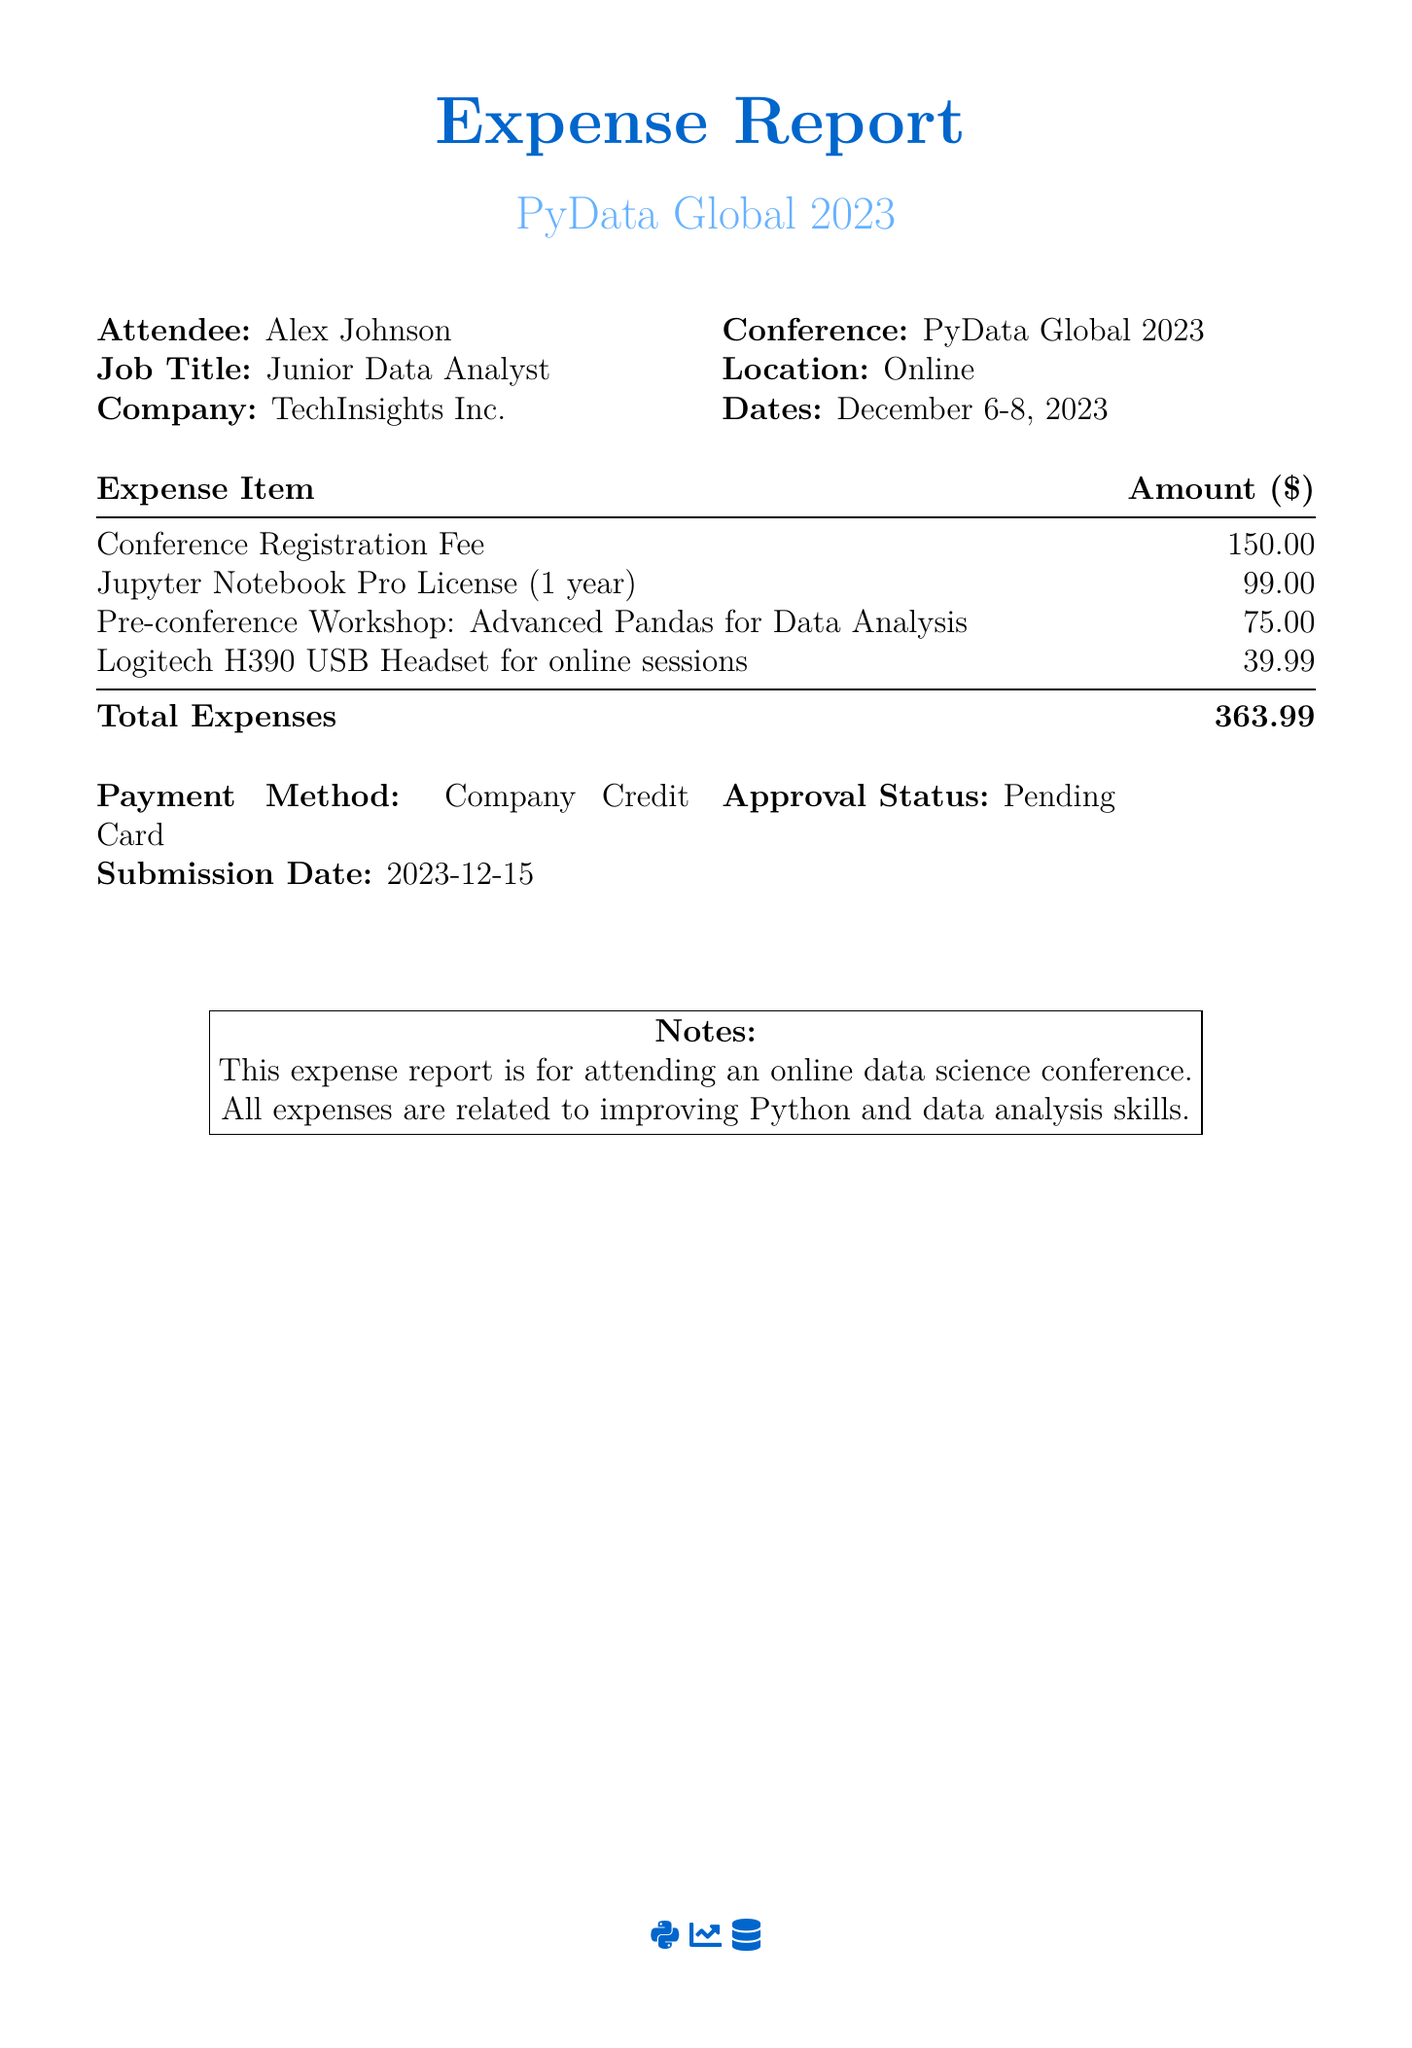what is the name of the attendee? The name of the attendee is listed in the document under "Attendee".
Answer: Alex Johnson what is the total amount of expenses? The total amount is found at the bottom of the expenses table.
Answer: 363.99 what was the location of the conference? The location is specified in the table where the conference details are mentioned.
Answer: Online what is the approval status for the expense report? The approval status can be found in the table detailing payment methods.
Answer: Pending how much was the conference registration fee? The conference registration fee is specifically listed in the expenses table.
Answer: 150.00 which workshop was attended before the conference? The document mentions a specific workshop that took place prior to the conference.
Answer: Advanced Pandas for Data Analysis when was the submission date of the expense report? The submission date is explicitly stated in the details provided in the table.
Answer: 2023-12-15 what payment method was used for the expenses? The payment method is detailed in the section covering payment and approval information.
Answer: Company Credit Card how much did the Jupyter Notebook Pro License cost? The cost of the Jupyter Notebook Pro License is directly listed in the expenses table.
Answer: 99.00 what is the purpose of the expenses listed? The purpose of the expenses is mentioned in the notes section of the document.
Answer: Improving Python and data analysis skills 